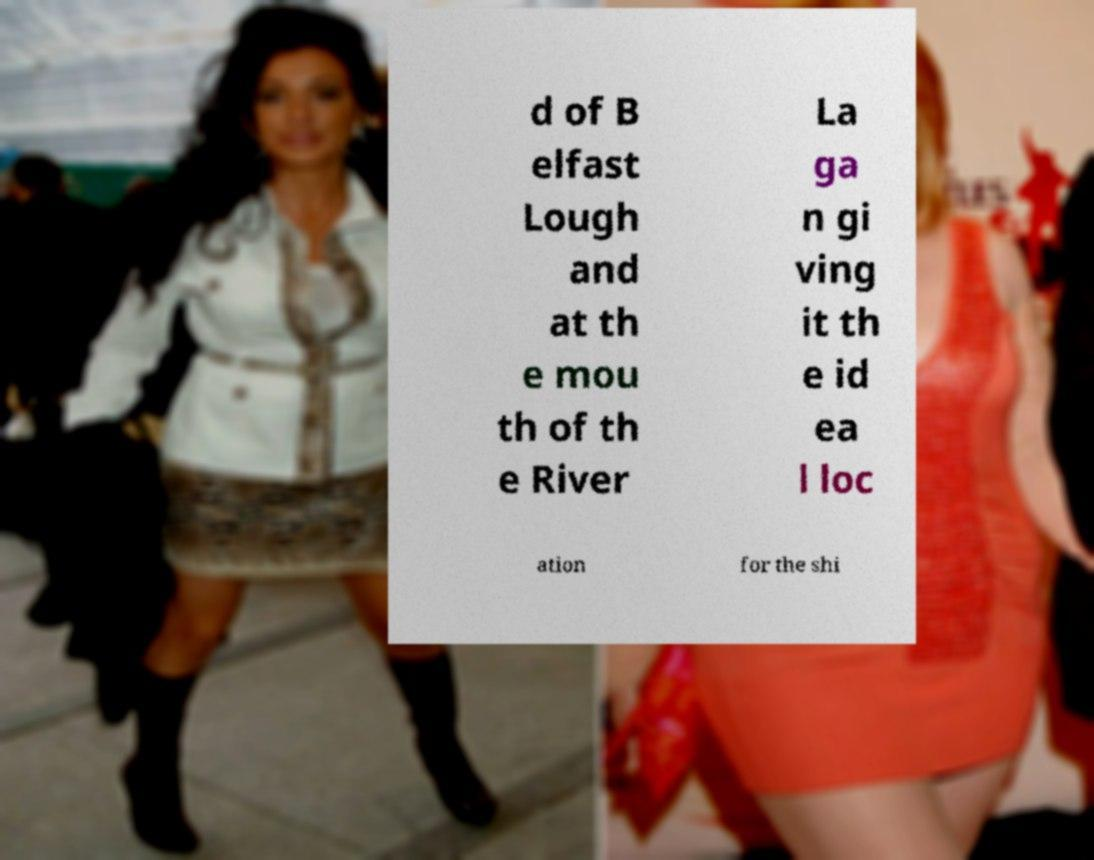Please read and relay the text visible in this image. What does it say? d of B elfast Lough and at th e mou th of th e River La ga n gi ving it th e id ea l loc ation for the shi 